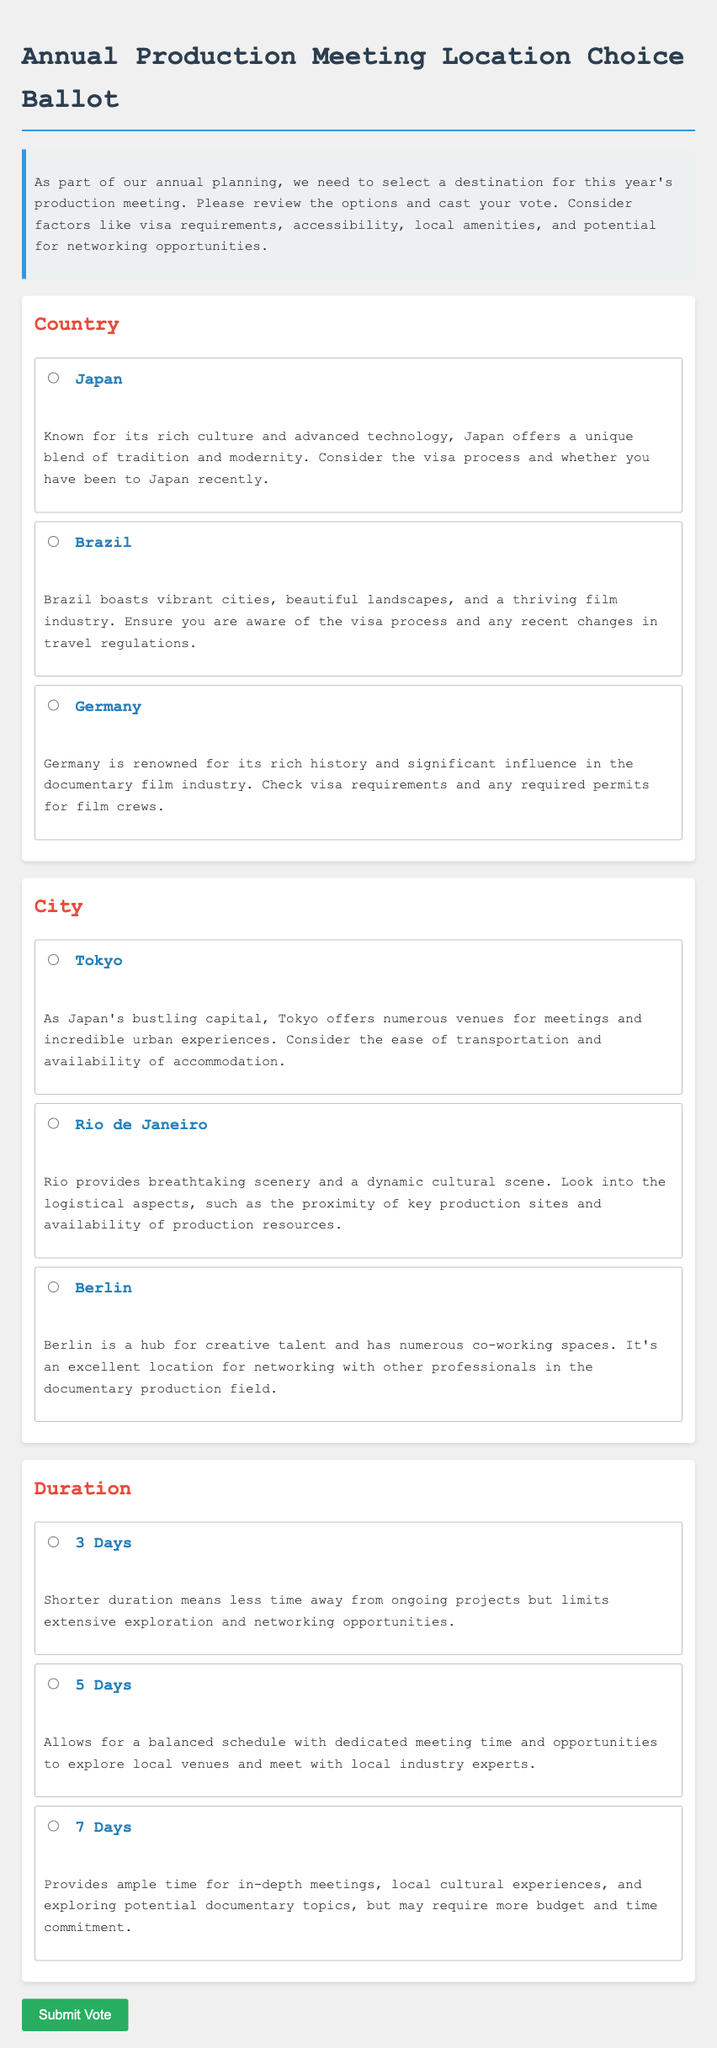What are the three countries listed in the ballot? The ballot presents three country options for the annual production meeting: Japan, Brazil, and Germany.
Answer: Japan, Brazil, Germany Which city corresponds to Brazil? In the City section of the ballot, Rio de Janeiro is the city option associated with Brazil.
Answer: Rio de Janeiro What is the maximum duration option available in the ballot? The ballot includes options for durations, with 7 Days being the longest available duration for the production meeting.
Answer: 7 Days Which country has a significant influence in the documentary film industry? According to the ballot, Germany is known for its rich history and significant influence in the documentary film industry.
Answer: Germany What is a key aspect to consider when choosing Tokyo as a meeting location? The ballot advises considering the ease of transportation and availability of accommodation when choosing Tokyo.
Answer: Ease of transportation What duration option allows for a balanced schedule with dedicated meeting time? The option of 5 Days is described in the ballot as allowing for a balanced schedule with dedicated meeting time.
Answer: 5 Days 